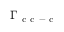Convert formula to latex. <formula><loc_0><loc_0><loc_500><loc_500>\Gamma _ { c c - c }</formula> 